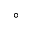Convert formula to latex. <formula><loc_0><loc_0><loc_500><loc_500>^ { \circ }</formula> 